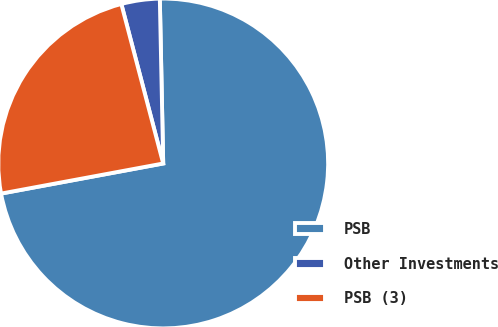Convert chart to OTSL. <chart><loc_0><loc_0><loc_500><loc_500><pie_chart><fcel>PSB<fcel>Other Investments<fcel>PSB (3)<nl><fcel>72.4%<fcel>3.76%<fcel>23.83%<nl></chart> 